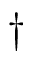<formula> <loc_0><loc_0><loc_500><loc_500>\dag</formula> 